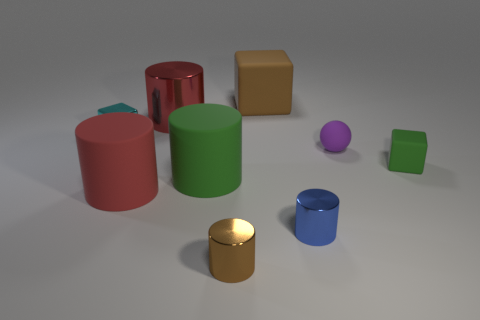What is the size of the other cylinder that is the same color as the big metallic cylinder?
Provide a succinct answer. Large. There is a thing that is the same color as the big metal cylinder; what is its shape?
Ensure brevity in your answer.  Cylinder. Is there a large brown thing that has the same shape as the big red rubber thing?
Offer a very short reply. No. There is a green rubber object that is the same size as the matte ball; what shape is it?
Your answer should be very brief. Cube. Is the color of the metal block the same as the large matte cylinder that is to the right of the large red rubber cylinder?
Ensure brevity in your answer.  No. How many metallic things are in front of the thing that is right of the purple rubber sphere?
Provide a succinct answer. 2. What size is the cylinder that is in front of the cyan block and behind the big red matte thing?
Ensure brevity in your answer.  Large. Are there any gray rubber cylinders of the same size as the cyan metal thing?
Offer a very short reply. No. Is the number of cyan objects that are in front of the brown rubber cube greater than the number of large red cylinders in front of the blue metallic cylinder?
Make the answer very short. Yes. Is the material of the tiny brown cylinder the same as the cube in front of the small purple matte object?
Offer a very short reply. No. 